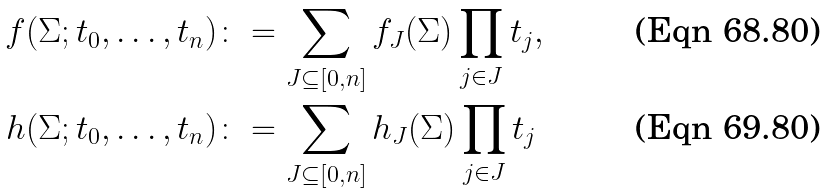<formula> <loc_0><loc_0><loc_500><loc_500>f ( \Sigma ; t _ { 0 } , \dots , t _ { n } ) & \colon = \sum _ { J \subseteq [ 0 , n ] } f _ { J } ( \Sigma ) \prod _ { j \in J } t _ { j } , \\ h ( \Sigma ; t _ { 0 } , \dots , t _ { n } ) & \colon = \sum _ { J \subseteq [ 0 , n ] } h _ { J } ( \Sigma ) \prod _ { j \in J } t _ { j }</formula> 